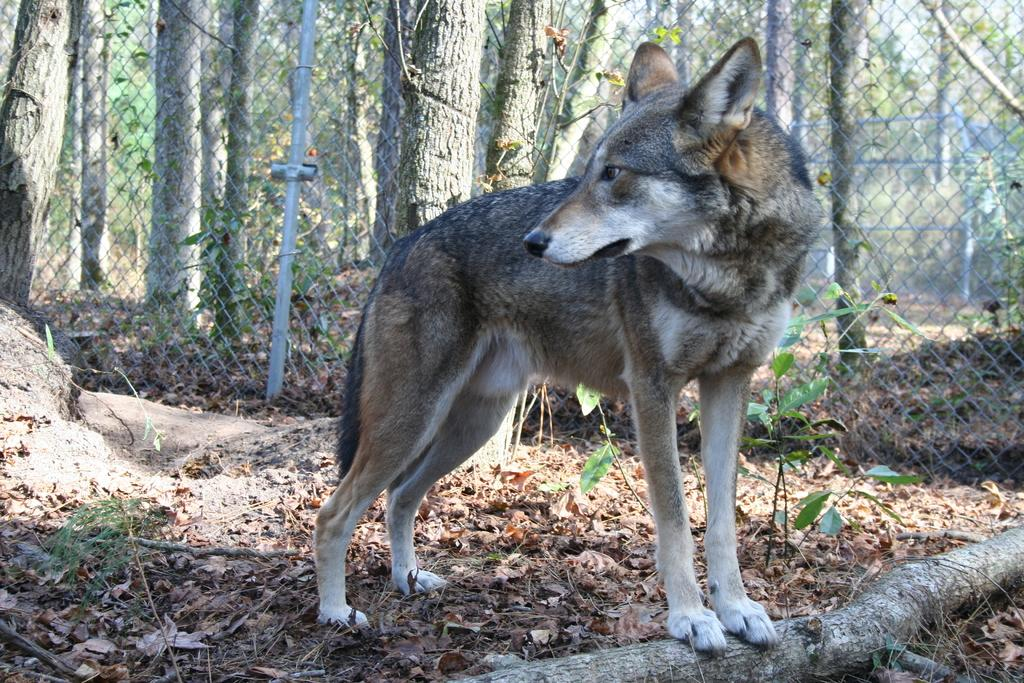What type of living organism can be seen in the image? There is an animal in the image. What other object can be seen in the image besides the animal? There is a plant in the image. What is the shape or structure in the middle of the image? There is a pipe in the middle of the image. Can you describe the mesh in the image? There is a mesh in between stems in the image. What type of pest can be seen causing damage to the plant in the image? There is no pest present in the image, and the plant appears to be healthy. 